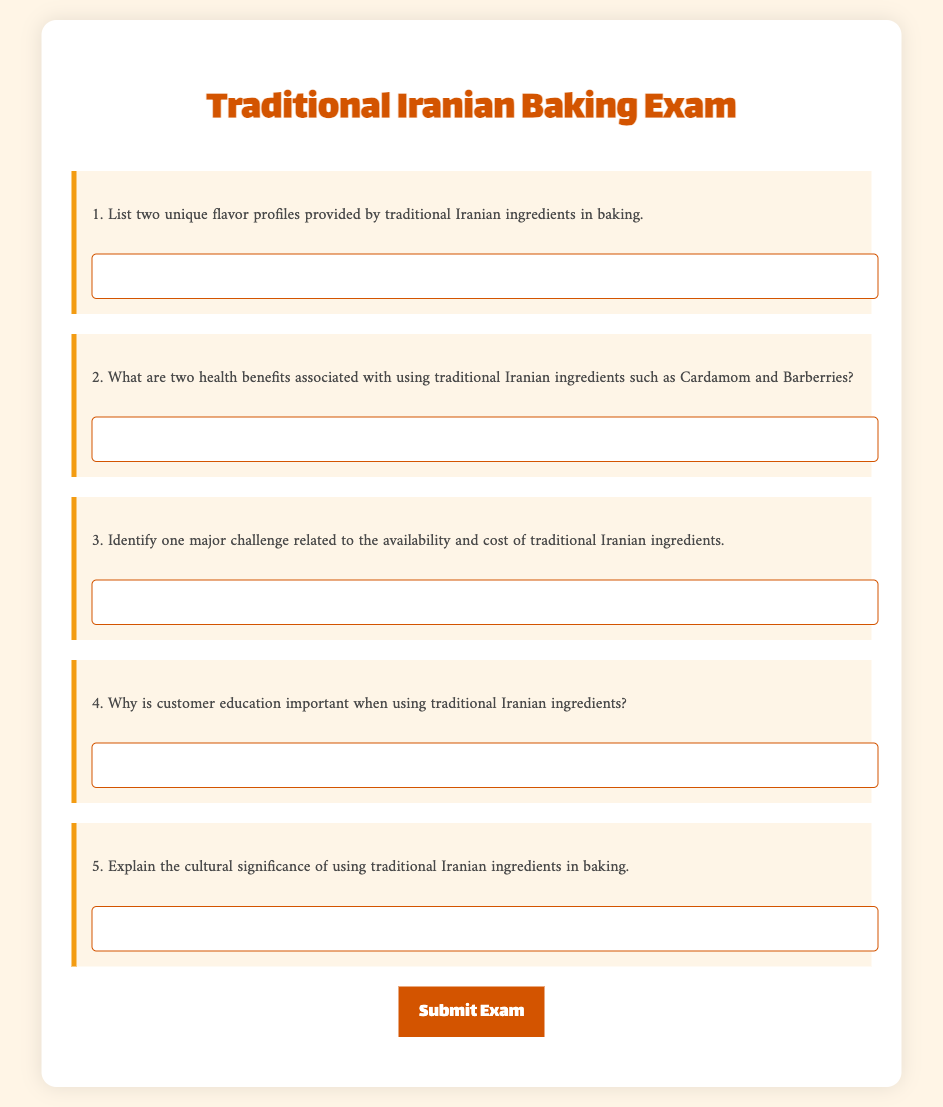What is the title of the exam? The title of the exam is displayed at the top of the document.
Answer: Traditional Iranian Baking Exam How many health benefits are mentioned in the second question? The second question specifically asks for two health benefits.
Answer: Two What unique flavor profiles are requested in the first question? The first question asks for two unique flavor profiles provided by traditional Iranian ingredients.
Answer: Two unique flavor profiles What is a major challenge related to traditional Iranian ingredients? The third question inquires about one major challenge regarding availability and cost.
Answer: Availability and cost Why is customer education emphasized in the exam? The fourth question asks for the importance of customer education when using traditional ingredients.
Answer: Importance of customer education What is the required response format for the answers? The document specifies that answers must be provided in a text input box for each question.
Answer: Text input box 